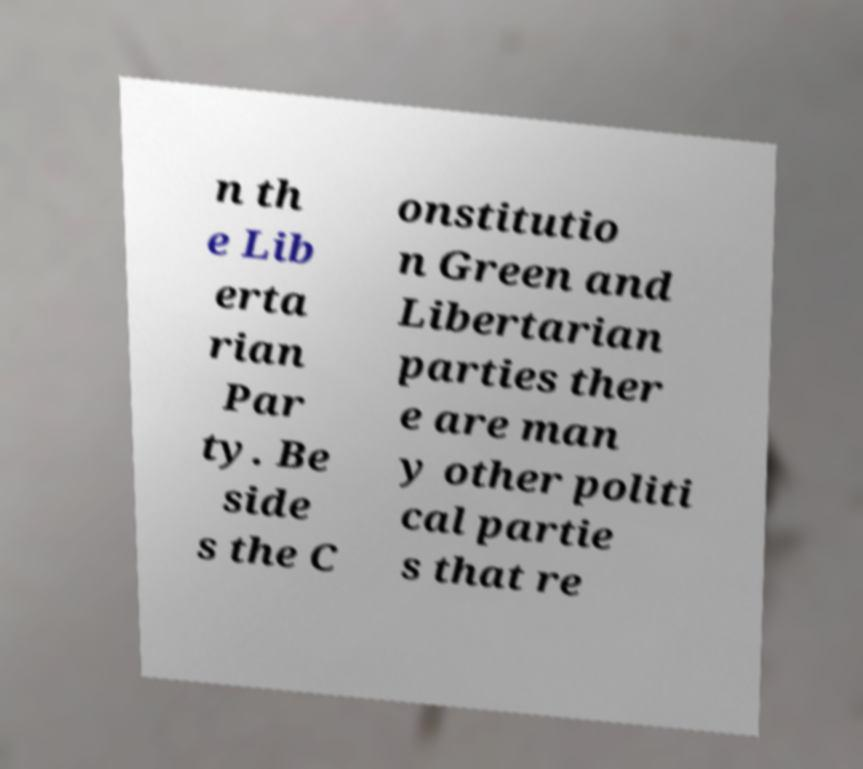Please identify and transcribe the text found in this image. n th e Lib erta rian Par ty. Be side s the C onstitutio n Green and Libertarian parties ther e are man y other politi cal partie s that re 